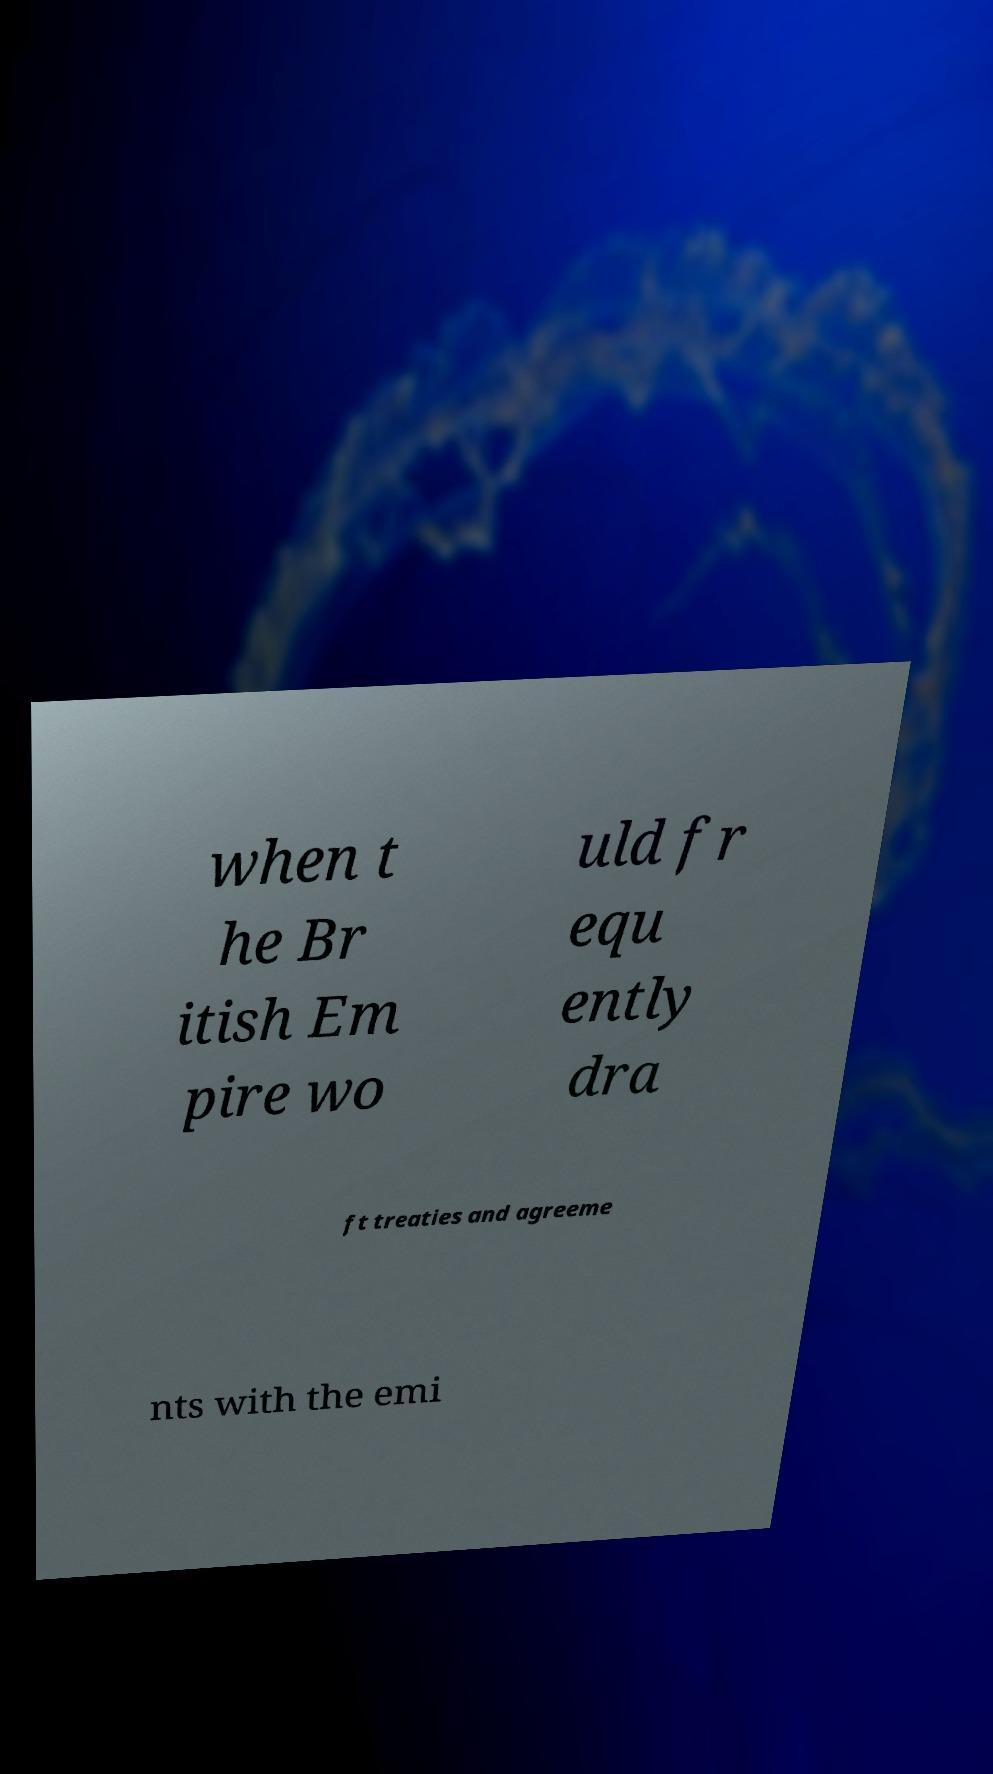Can you read and provide the text displayed in the image?This photo seems to have some interesting text. Can you extract and type it out for me? when t he Br itish Em pire wo uld fr equ ently dra ft treaties and agreeme nts with the emi 